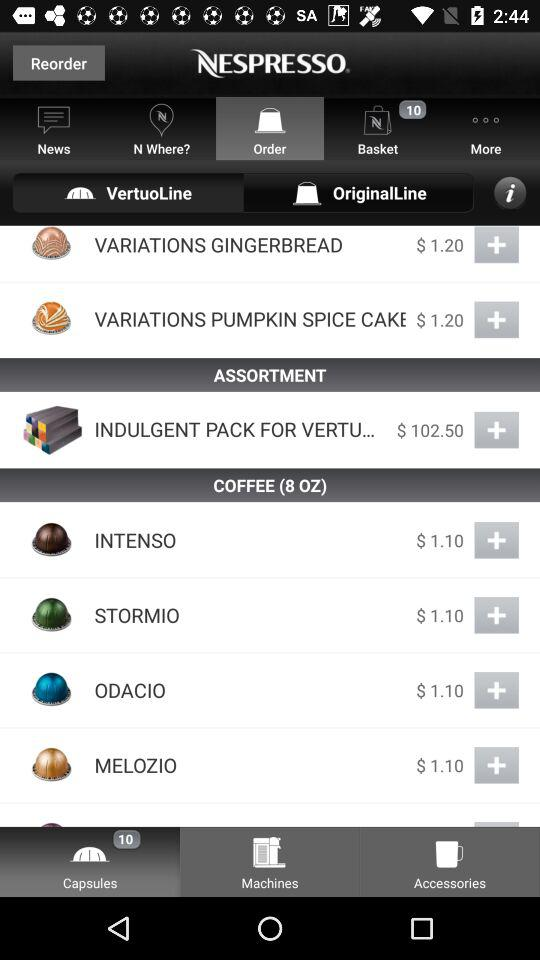What is the number of items in "Capsules"? The number of items in "Capsules" is 10. 